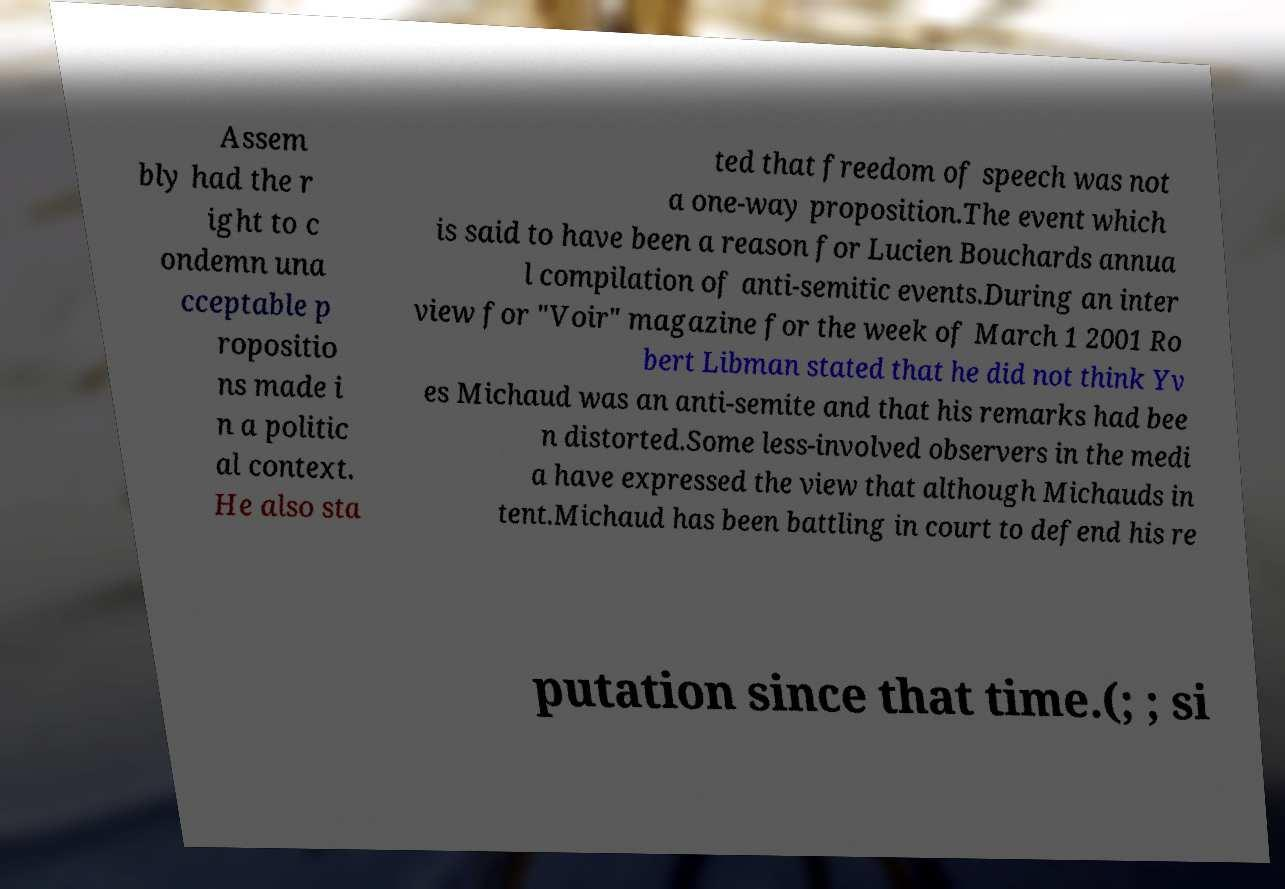Can you read and provide the text displayed in the image?This photo seems to have some interesting text. Can you extract and type it out for me? Assem bly had the r ight to c ondemn una cceptable p ropositio ns made i n a politic al context. He also sta ted that freedom of speech was not a one-way proposition.The event which is said to have been a reason for Lucien Bouchards annua l compilation of anti-semitic events.During an inter view for "Voir" magazine for the week of March 1 2001 Ro bert Libman stated that he did not think Yv es Michaud was an anti-semite and that his remarks had bee n distorted.Some less-involved observers in the medi a have expressed the view that although Michauds in tent.Michaud has been battling in court to defend his re putation since that time.(; ; si 